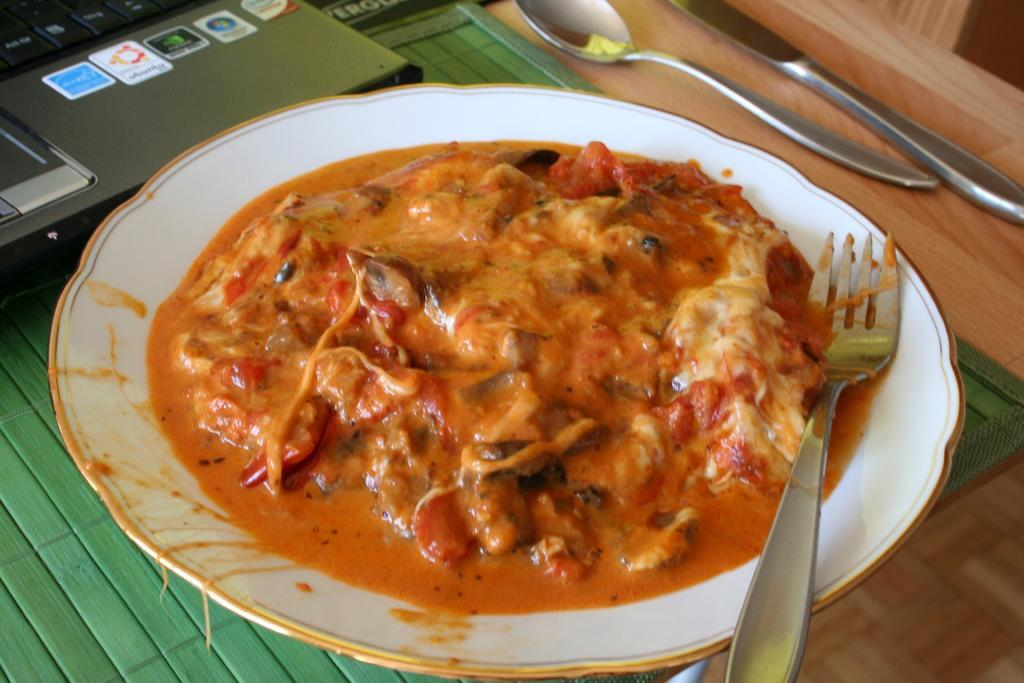What is located in the center of the image? There is a plate in the center of the image. What is on the plate? There are food items on the plate. What utensil is placed on the plate? There is a fork in the plate. What other utensil can be seen in the image? There is a spoon visible in the image. Can you identify another utensil in the image? Yes, there appears to be a knife in the image. What electronic device is present in the image? There is a laptop on the table. What type of plantation can be seen in the background of the image? There is no plantation visible in the image; it features a plate with food items, utensils, and a laptop on a table. 